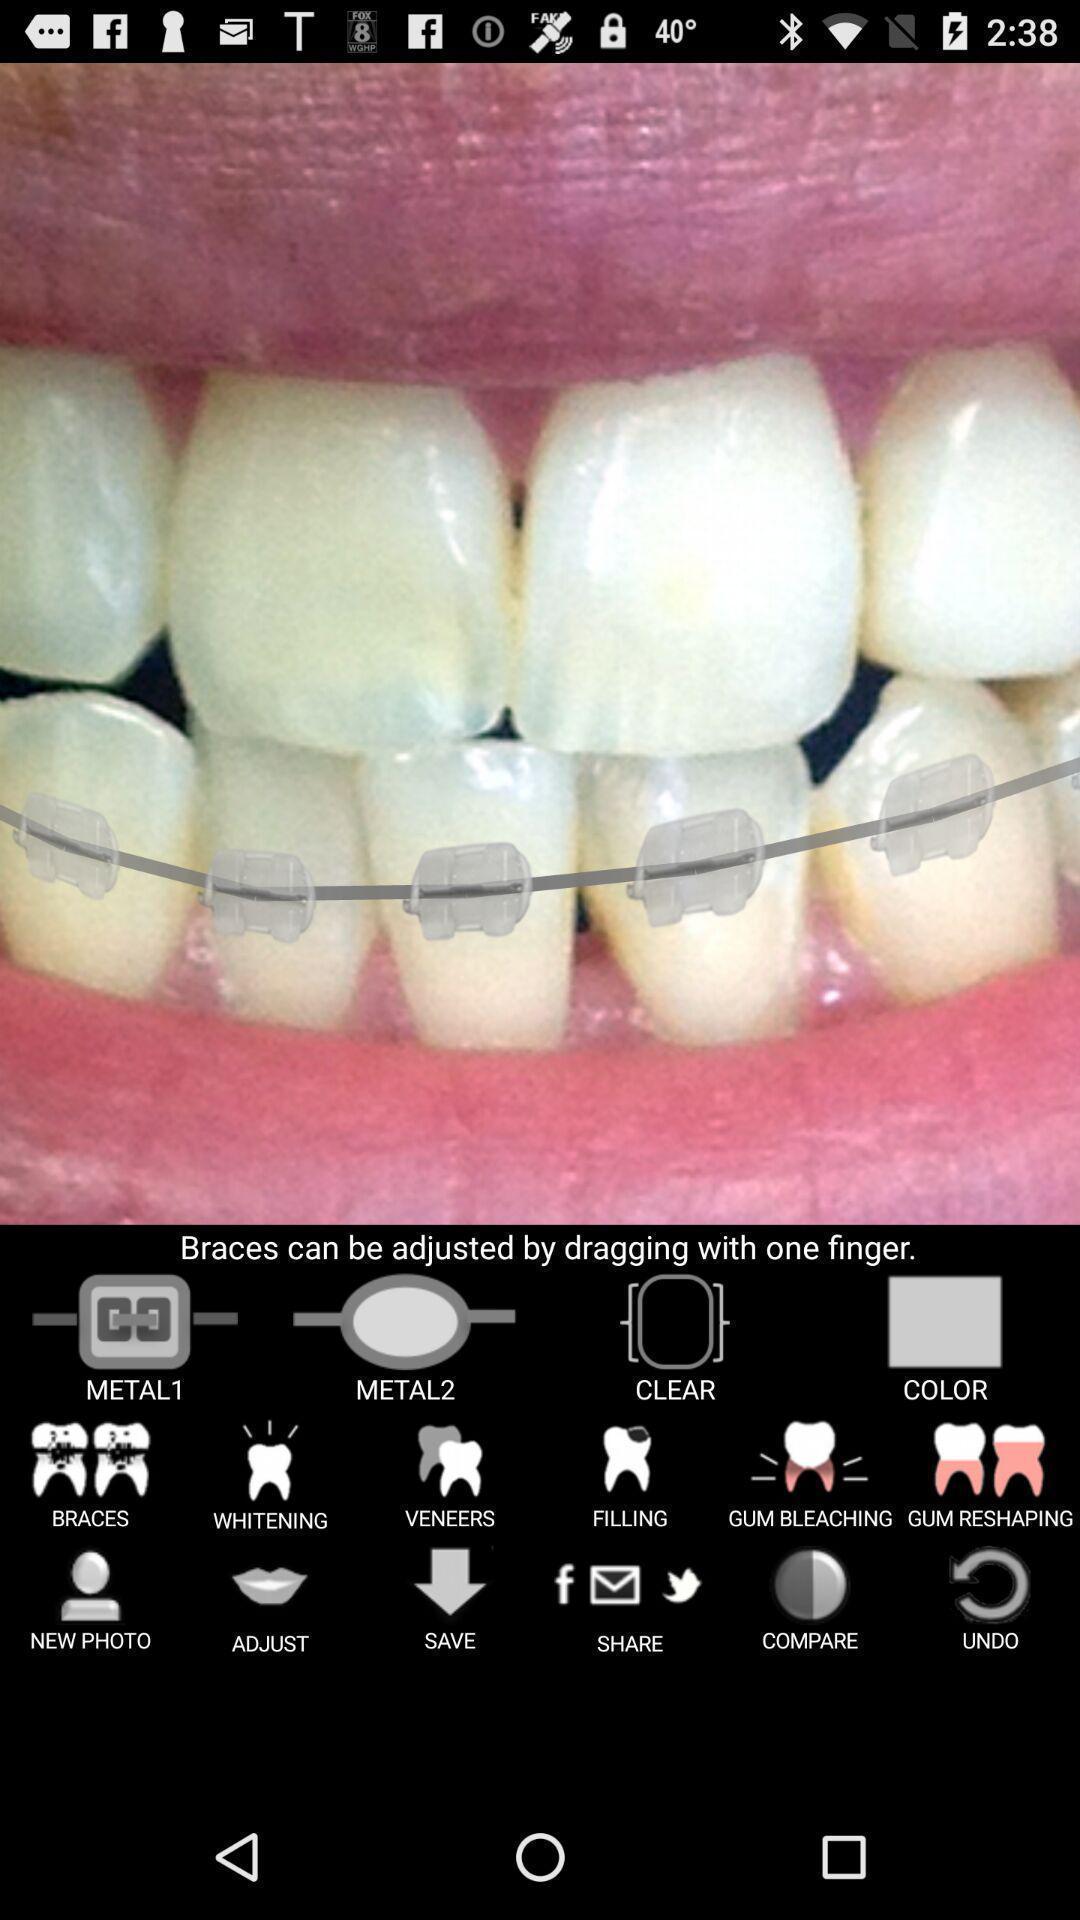Give me a summary of this screen capture. Screen shows image of teeth with multiple options. 